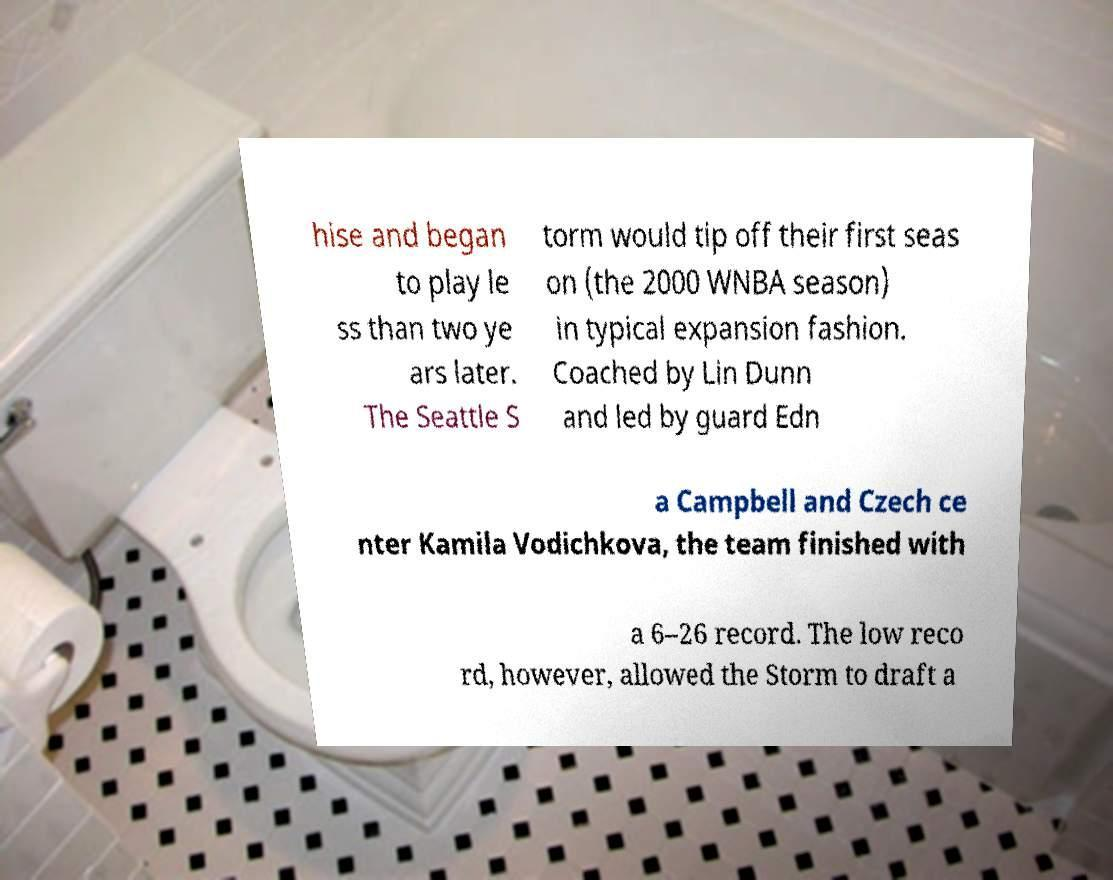Please identify and transcribe the text found in this image. hise and began to play le ss than two ye ars later. The Seattle S torm would tip off their first seas on (the 2000 WNBA season) in typical expansion fashion. Coached by Lin Dunn and led by guard Edn a Campbell and Czech ce nter Kamila Vodichkova, the team finished with a 6–26 record. The low reco rd, however, allowed the Storm to draft a 